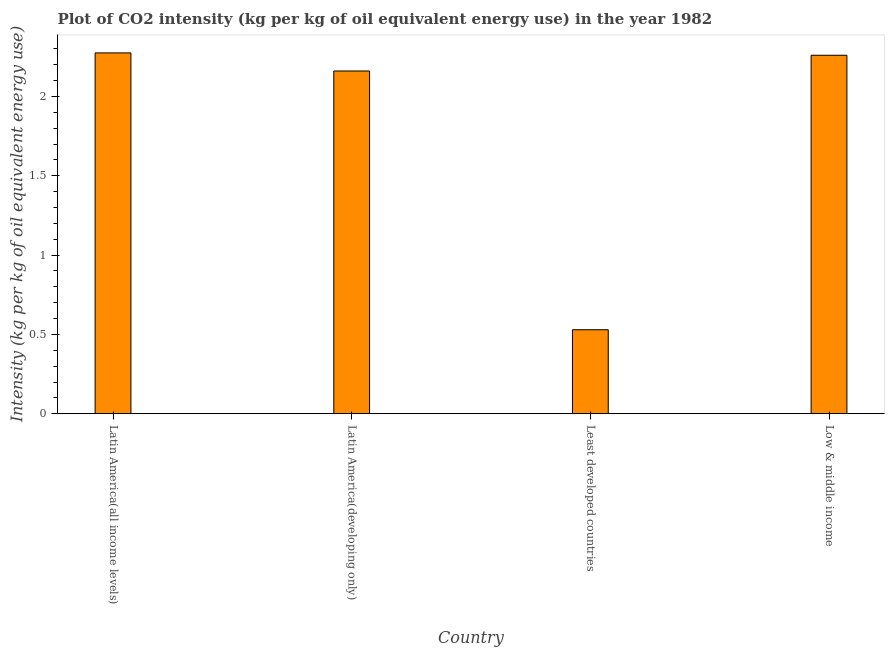Does the graph contain any zero values?
Provide a succinct answer. No. What is the title of the graph?
Offer a very short reply. Plot of CO2 intensity (kg per kg of oil equivalent energy use) in the year 1982. What is the label or title of the Y-axis?
Make the answer very short. Intensity (kg per kg of oil equivalent energy use). What is the co2 intensity in Least developed countries?
Keep it short and to the point. 0.53. Across all countries, what is the maximum co2 intensity?
Make the answer very short. 2.27. Across all countries, what is the minimum co2 intensity?
Make the answer very short. 0.53. In which country was the co2 intensity maximum?
Give a very brief answer. Latin America(all income levels). In which country was the co2 intensity minimum?
Keep it short and to the point. Least developed countries. What is the sum of the co2 intensity?
Provide a short and direct response. 7.22. What is the difference between the co2 intensity in Least developed countries and Low & middle income?
Make the answer very short. -1.73. What is the average co2 intensity per country?
Give a very brief answer. 1.81. What is the median co2 intensity?
Offer a very short reply. 2.21. In how many countries, is the co2 intensity greater than 0.7 kg?
Provide a short and direct response. 3. What is the ratio of the co2 intensity in Latin America(developing only) to that in Least developed countries?
Ensure brevity in your answer.  4.08. Is the co2 intensity in Latin America(all income levels) less than that in Least developed countries?
Your answer should be very brief. No. What is the difference between the highest and the second highest co2 intensity?
Offer a very short reply. 0.01. What is the difference between the highest and the lowest co2 intensity?
Your response must be concise. 1.75. In how many countries, is the co2 intensity greater than the average co2 intensity taken over all countries?
Offer a terse response. 3. How many bars are there?
Give a very brief answer. 4. What is the Intensity (kg per kg of oil equivalent energy use) of Latin America(all income levels)?
Ensure brevity in your answer.  2.27. What is the Intensity (kg per kg of oil equivalent energy use) of Latin America(developing only)?
Your response must be concise. 2.16. What is the Intensity (kg per kg of oil equivalent energy use) of Least developed countries?
Provide a short and direct response. 0.53. What is the Intensity (kg per kg of oil equivalent energy use) of Low & middle income?
Your answer should be very brief. 2.26. What is the difference between the Intensity (kg per kg of oil equivalent energy use) in Latin America(all income levels) and Latin America(developing only)?
Provide a short and direct response. 0.11. What is the difference between the Intensity (kg per kg of oil equivalent energy use) in Latin America(all income levels) and Least developed countries?
Provide a succinct answer. 1.75. What is the difference between the Intensity (kg per kg of oil equivalent energy use) in Latin America(all income levels) and Low & middle income?
Provide a succinct answer. 0.01. What is the difference between the Intensity (kg per kg of oil equivalent energy use) in Latin America(developing only) and Least developed countries?
Provide a succinct answer. 1.63. What is the difference between the Intensity (kg per kg of oil equivalent energy use) in Latin America(developing only) and Low & middle income?
Provide a succinct answer. -0.1. What is the difference between the Intensity (kg per kg of oil equivalent energy use) in Least developed countries and Low & middle income?
Provide a short and direct response. -1.73. What is the ratio of the Intensity (kg per kg of oil equivalent energy use) in Latin America(all income levels) to that in Latin America(developing only)?
Your answer should be very brief. 1.05. What is the ratio of the Intensity (kg per kg of oil equivalent energy use) in Latin America(all income levels) to that in Least developed countries?
Provide a succinct answer. 4.3. What is the ratio of the Intensity (kg per kg of oil equivalent energy use) in Latin America(developing only) to that in Least developed countries?
Your answer should be very brief. 4.08. What is the ratio of the Intensity (kg per kg of oil equivalent energy use) in Latin America(developing only) to that in Low & middle income?
Keep it short and to the point. 0.96. What is the ratio of the Intensity (kg per kg of oil equivalent energy use) in Least developed countries to that in Low & middle income?
Offer a very short reply. 0.23. 